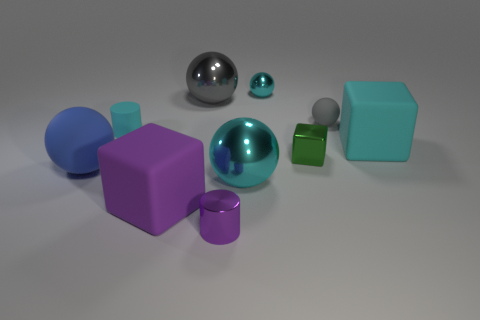There is a metal sphere that is the same size as the metal block; what is its color?
Offer a terse response. Cyan. Are there any shiny things of the same color as the small cube?
Your answer should be very brief. No. What is the material of the tiny green block?
Your response must be concise. Metal. How many matte objects are there?
Ensure brevity in your answer.  5. There is a tiny ball on the right side of the small cyan ball; is its color the same as the big block that is on the right side of the small cyan metal ball?
Your response must be concise. No. There is a matte object that is the same color as the small rubber cylinder; what is its size?
Your response must be concise. Large. How many other objects are there of the same size as the cyan rubber cylinder?
Make the answer very short. 4. What color is the large sphere right of the purple cylinder?
Keep it short and to the point. Cyan. Is the cylinder in front of the large blue ball made of the same material as the big purple thing?
Give a very brief answer. No. What number of cyan things are in front of the shiny cube and behind the gray metallic object?
Your response must be concise. 0. 